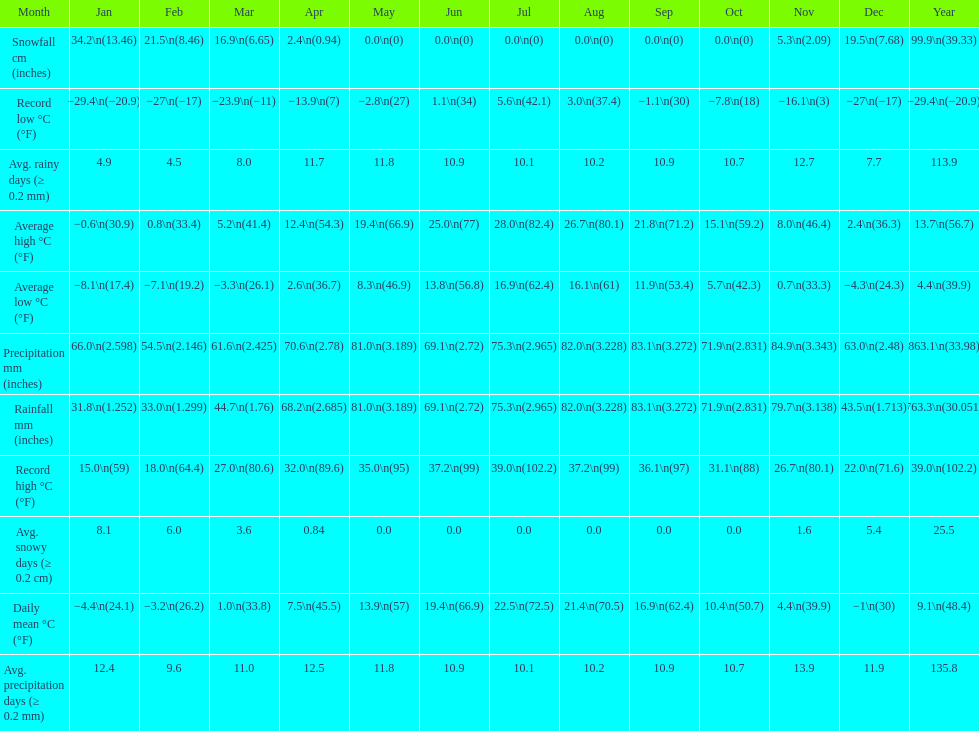Would you be able to parse every entry in this table? {'header': ['Month', 'Jan', 'Feb', 'Mar', 'Apr', 'May', 'Jun', 'Jul', 'Aug', 'Sep', 'Oct', 'Nov', 'Dec', 'Year'], 'rows': [['Snowfall cm (inches)', '34.2\\n(13.46)', '21.5\\n(8.46)', '16.9\\n(6.65)', '2.4\\n(0.94)', '0.0\\n(0)', '0.0\\n(0)', '0.0\\n(0)', '0.0\\n(0)', '0.0\\n(0)', '0.0\\n(0)', '5.3\\n(2.09)', '19.5\\n(7.68)', '99.9\\n(39.33)'], ['Record low °C (°F)', '−29.4\\n(−20.9)', '−27\\n(−17)', '−23.9\\n(−11)', '−13.9\\n(7)', '−2.8\\n(27)', '1.1\\n(34)', '5.6\\n(42.1)', '3.0\\n(37.4)', '−1.1\\n(30)', '−7.8\\n(18)', '−16.1\\n(3)', '−27\\n(−17)', '−29.4\\n(−20.9)'], ['Avg. rainy days (≥ 0.2 mm)', '4.9', '4.5', '8.0', '11.7', '11.8', '10.9', '10.1', '10.2', '10.9', '10.7', '12.7', '7.7', '113.9'], ['Average high °C (°F)', '−0.6\\n(30.9)', '0.8\\n(33.4)', '5.2\\n(41.4)', '12.4\\n(54.3)', '19.4\\n(66.9)', '25.0\\n(77)', '28.0\\n(82.4)', '26.7\\n(80.1)', '21.8\\n(71.2)', '15.1\\n(59.2)', '8.0\\n(46.4)', '2.4\\n(36.3)', '13.7\\n(56.7)'], ['Average low °C (°F)', '−8.1\\n(17.4)', '−7.1\\n(19.2)', '−3.3\\n(26.1)', '2.6\\n(36.7)', '8.3\\n(46.9)', '13.8\\n(56.8)', '16.9\\n(62.4)', '16.1\\n(61)', '11.9\\n(53.4)', '5.7\\n(42.3)', '0.7\\n(33.3)', '−4.3\\n(24.3)', '4.4\\n(39.9)'], ['Precipitation mm (inches)', '66.0\\n(2.598)', '54.5\\n(2.146)', '61.6\\n(2.425)', '70.6\\n(2.78)', '81.0\\n(3.189)', '69.1\\n(2.72)', '75.3\\n(2.965)', '82.0\\n(3.228)', '83.1\\n(3.272)', '71.9\\n(2.831)', '84.9\\n(3.343)', '63.0\\n(2.48)', '863.1\\n(33.98)'], ['Rainfall mm (inches)', '31.8\\n(1.252)', '33.0\\n(1.299)', '44.7\\n(1.76)', '68.2\\n(2.685)', '81.0\\n(3.189)', '69.1\\n(2.72)', '75.3\\n(2.965)', '82.0\\n(3.228)', '83.1\\n(3.272)', '71.9\\n(2.831)', '79.7\\n(3.138)', '43.5\\n(1.713)', '763.3\\n(30.051)'], ['Record high °C (°F)', '15.0\\n(59)', '18.0\\n(64.4)', '27.0\\n(80.6)', '32.0\\n(89.6)', '35.0\\n(95)', '37.2\\n(99)', '39.0\\n(102.2)', '37.2\\n(99)', '36.1\\n(97)', '31.1\\n(88)', '26.7\\n(80.1)', '22.0\\n(71.6)', '39.0\\n(102.2)'], ['Avg. snowy days (≥ 0.2 cm)', '8.1', '6.0', '3.6', '0.84', '0.0', '0.0', '0.0', '0.0', '0.0', '0.0', '1.6', '5.4', '25.5'], ['Daily mean °C (°F)', '−4.4\\n(24.1)', '−3.2\\n(26.2)', '1.0\\n(33.8)', '7.5\\n(45.5)', '13.9\\n(57)', '19.4\\n(66.9)', '22.5\\n(72.5)', '21.4\\n(70.5)', '16.9\\n(62.4)', '10.4\\n(50.7)', '4.4\\n(39.9)', '−1\\n(30)', '9.1\\n(48.4)'], ['Avg. precipitation days (≥ 0.2 mm)', '12.4', '9.6', '11.0', '12.5', '11.8', '10.9', '10.1', '10.2', '10.9', '10.7', '13.9', '11.9', '135.8']]} Between january, october and december which month had the most rainfall? October. 